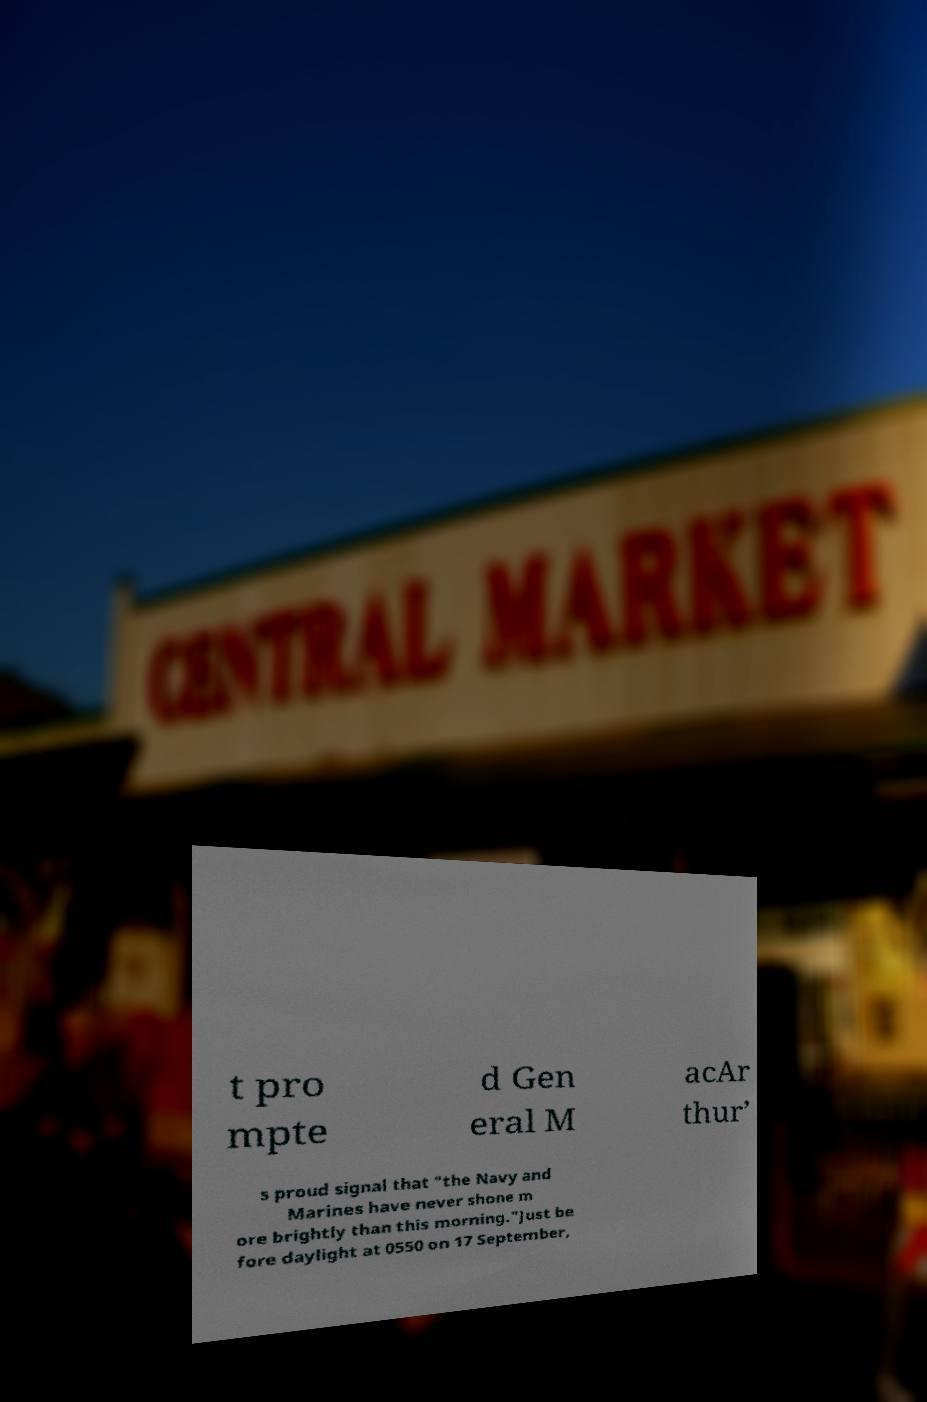I need the written content from this picture converted into text. Can you do that? t pro mpte d Gen eral M acAr thur’ s proud signal that "the Navy and Marines have never shone m ore brightly than this morning."Just be fore daylight at 0550 on 17 September, 